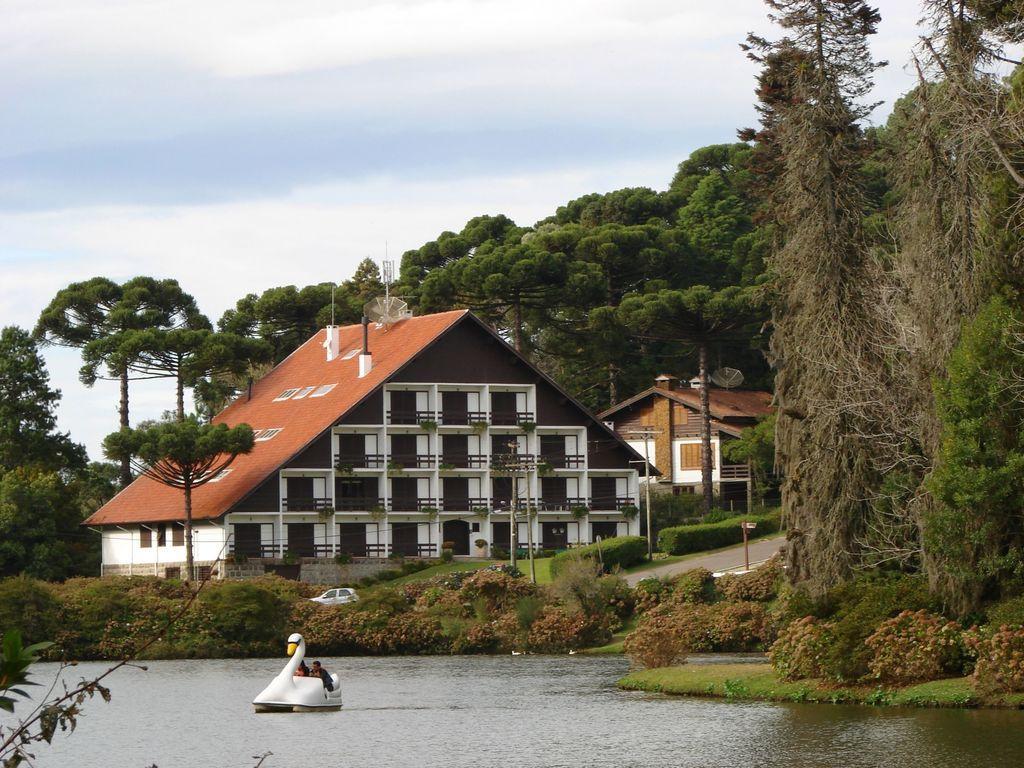How would you summarize this image in a sentence or two? In this image I can see water and in it I can see a white colour boat. I can also see few people over here and in background I can see plants, number of trees, buildings and the sky. I can also see few poles, road and a car. 